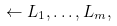Convert formula to latex. <formula><loc_0><loc_0><loc_500><loc_500>\leftarrow L _ { 1 } , \dots , L _ { m } ,</formula> 